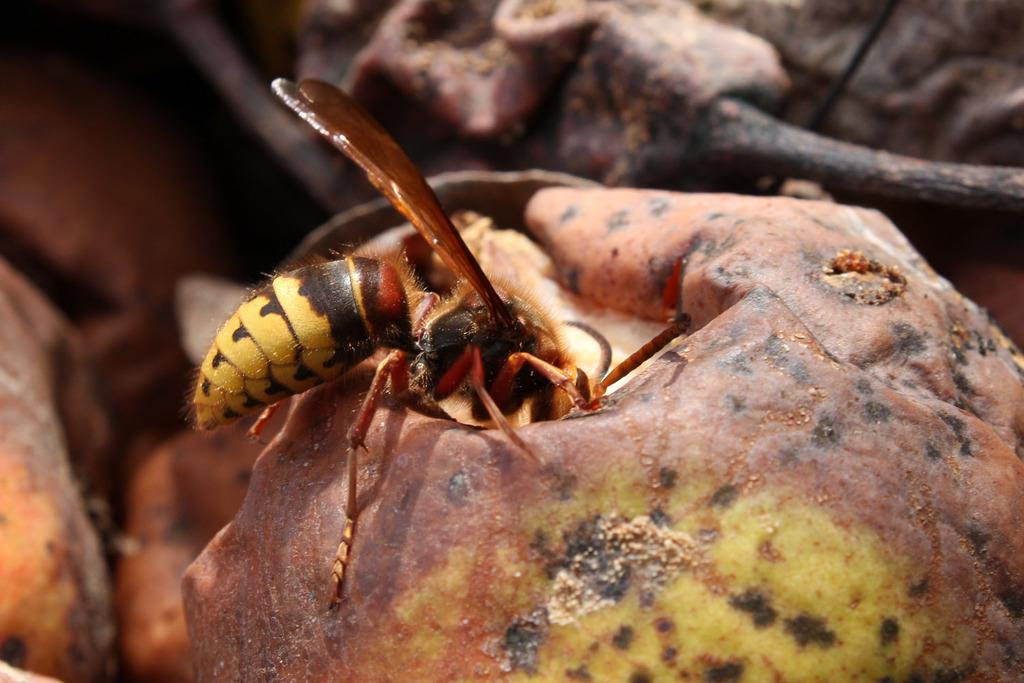What is the main subject of the image? There is an insect on a fruit in the image. Can you describe the background of the image? The background of the image is blurred. Where is the queen sitting in the image? There is no queen present in the image; it features an insect on a fruit with a blurred background. How many pigs can be seen in the image? There are no pigs present in the image. 